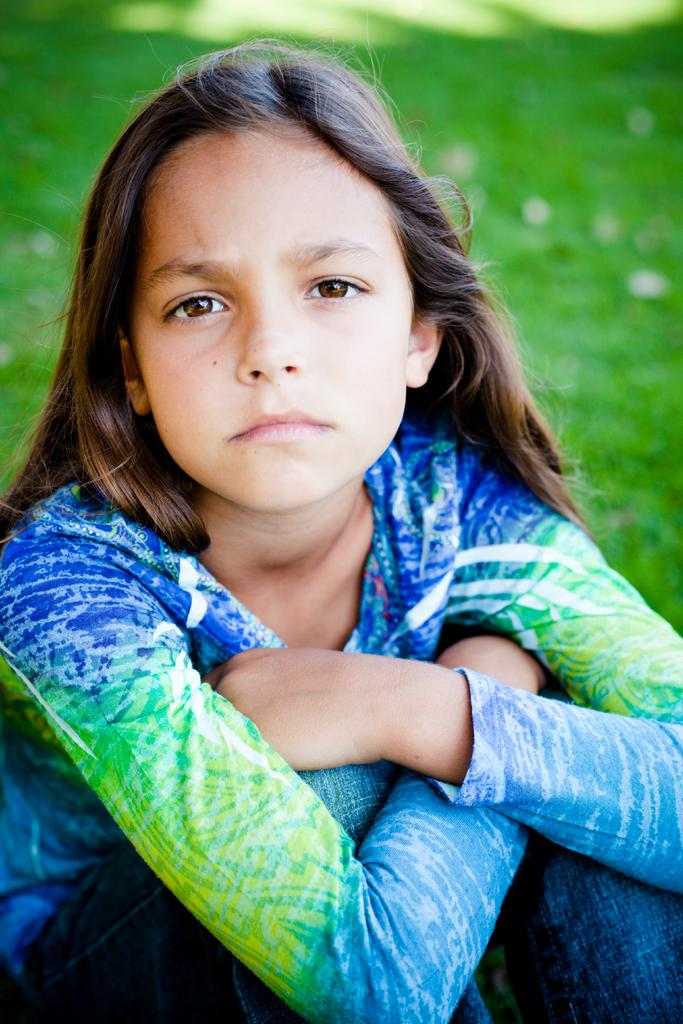Who is the main subject in the image? There is a girl in the image. What is the girl doing in the image? The girl is sitting on a grassland. What type of pain is the girl experiencing in the image? There is no indication in the image that the girl is experiencing any pain. 